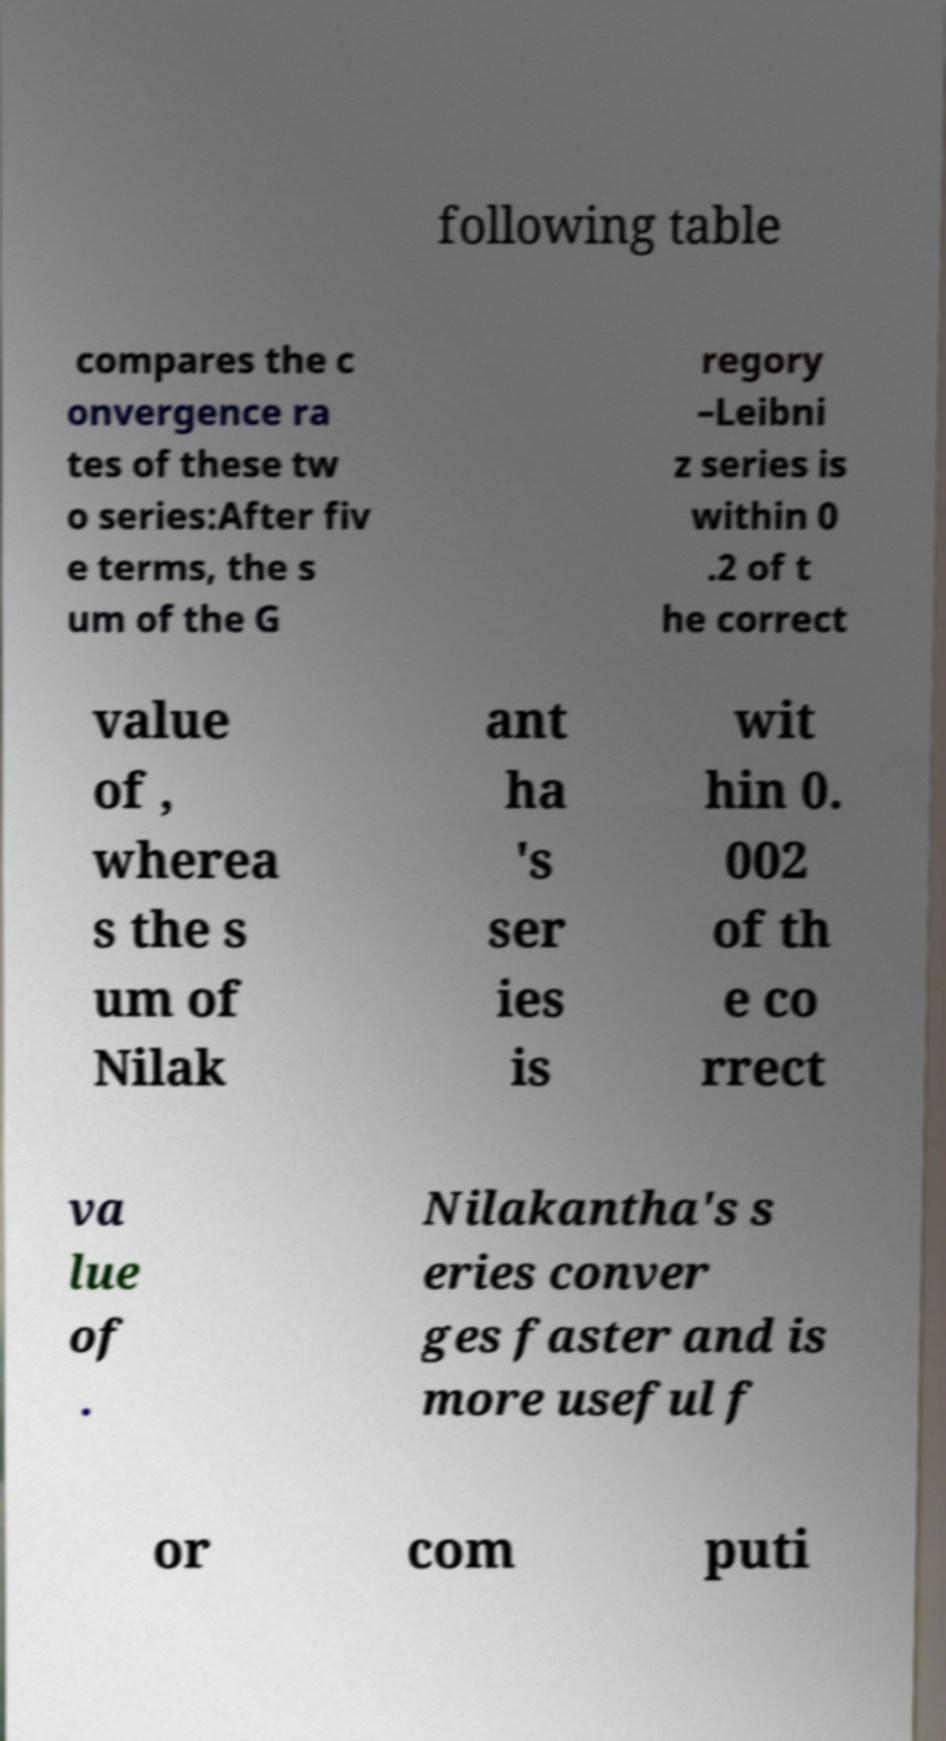Please identify and transcribe the text found in this image. following table compares the c onvergence ra tes of these tw o series:After fiv e terms, the s um of the G regory –Leibni z series is within 0 .2 of t he correct value of , wherea s the s um of Nilak ant ha 's ser ies is wit hin 0. 002 of th e co rrect va lue of . Nilakantha's s eries conver ges faster and is more useful f or com puti 